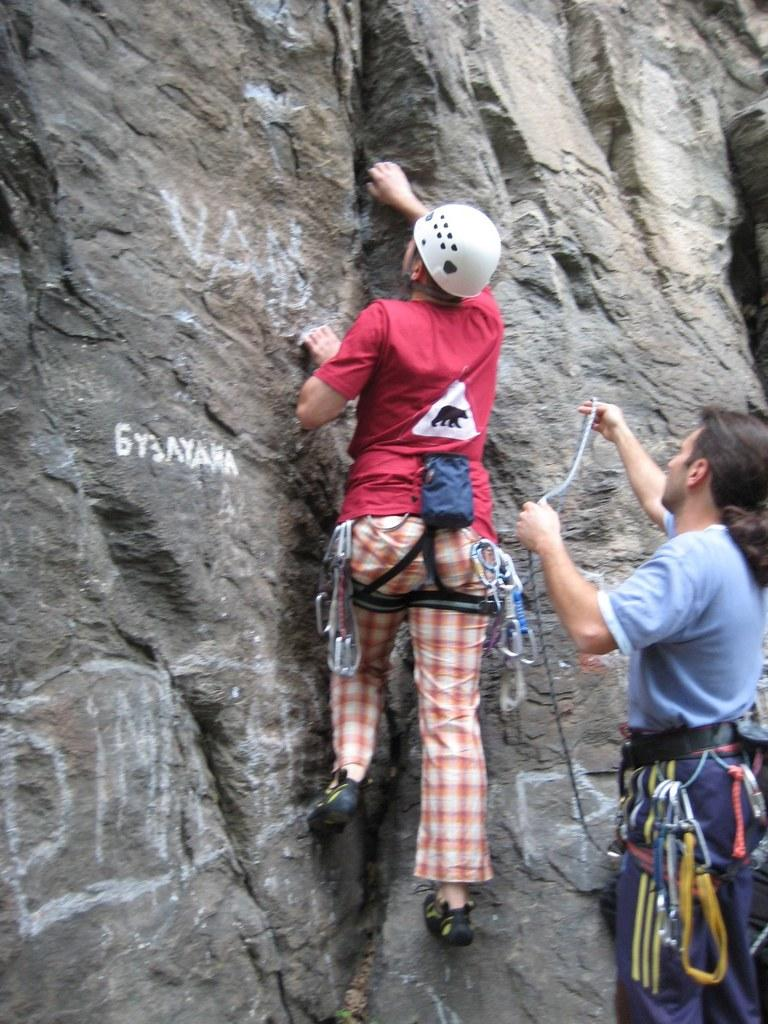What is the main activity taking place in the image? There is a person climbing a mountain in the image. Can you describe the other person in the image? There is a person standing in front of the mountain in the image. What is the person standing in front of the mountain holding? The person standing in front of the mountain is holding a rope. What type of jam is being spread on the edge of the mountain in the image? There is no jam or spreading activity present in the image; it features a person climbing a mountain and another person holding a rope. 